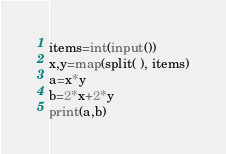<code> <loc_0><loc_0><loc_500><loc_500><_Python_>items=int(input())
x,y=map(split( ), items)
a=x*y
b=2*x+2*y
print(a,b)</code> 